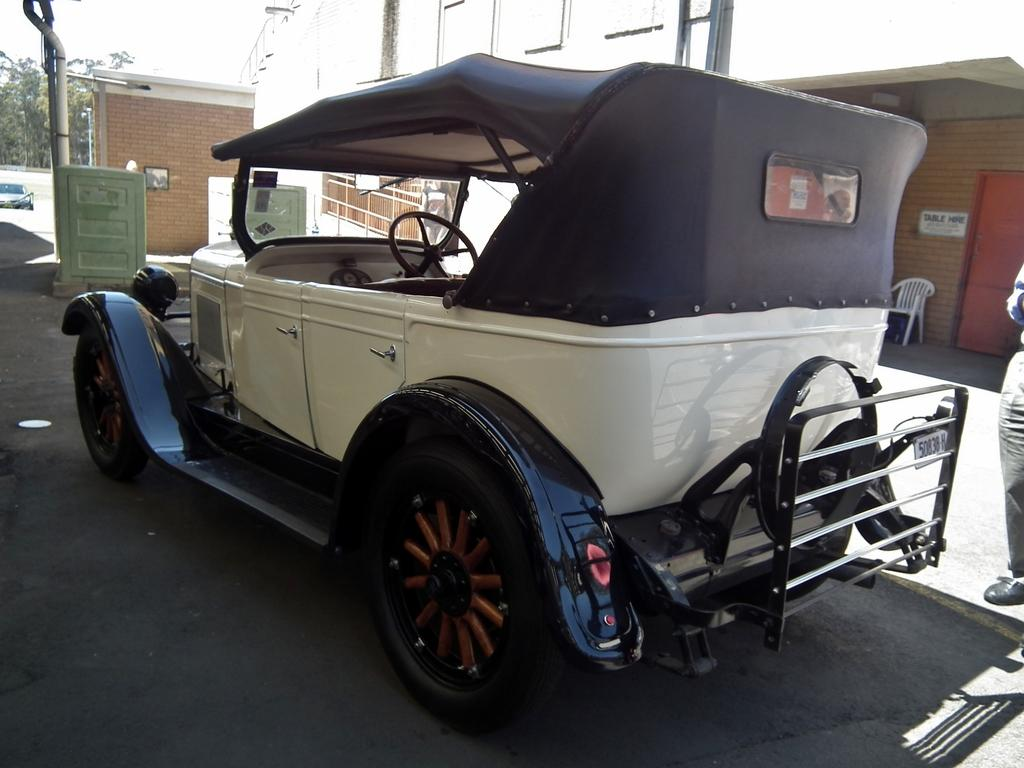What is the main subject of the image? There is a car in the image. Can you describe the human in the image? There is a human standing on the right side of the image. What type of structure is visible in the image? There is a building in the image. What type of vegetation is present in the image? There are trees in the image. Are there any other vehicles in the image? Yes, there is another car on the left side of the image. What type of furniture is on the right side of the image? There is a chair on the right side of the image. How many eggs are visible on the island in the image? There is no island or eggs present in the image. 